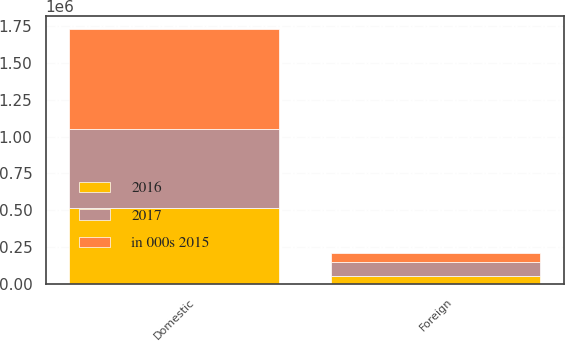<chart> <loc_0><loc_0><loc_500><loc_500><stacked_bar_chart><ecel><fcel>Domestic<fcel>Foreign<nl><fcel>2017<fcel>535378<fcel>93909<nl><fcel>2016<fcel>513746<fcel>55733<nl><fcel>in 000s 2015<fcel>682744<fcel>60061<nl></chart> 